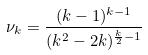Convert formula to latex. <formula><loc_0><loc_0><loc_500><loc_500>\nu _ { k } = \frac { ( k - 1 ) ^ { k - 1 } } { ( k ^ { 2 } - 2 k ) ^ { \frac { k } { 2 } - 1 } }</formula> 